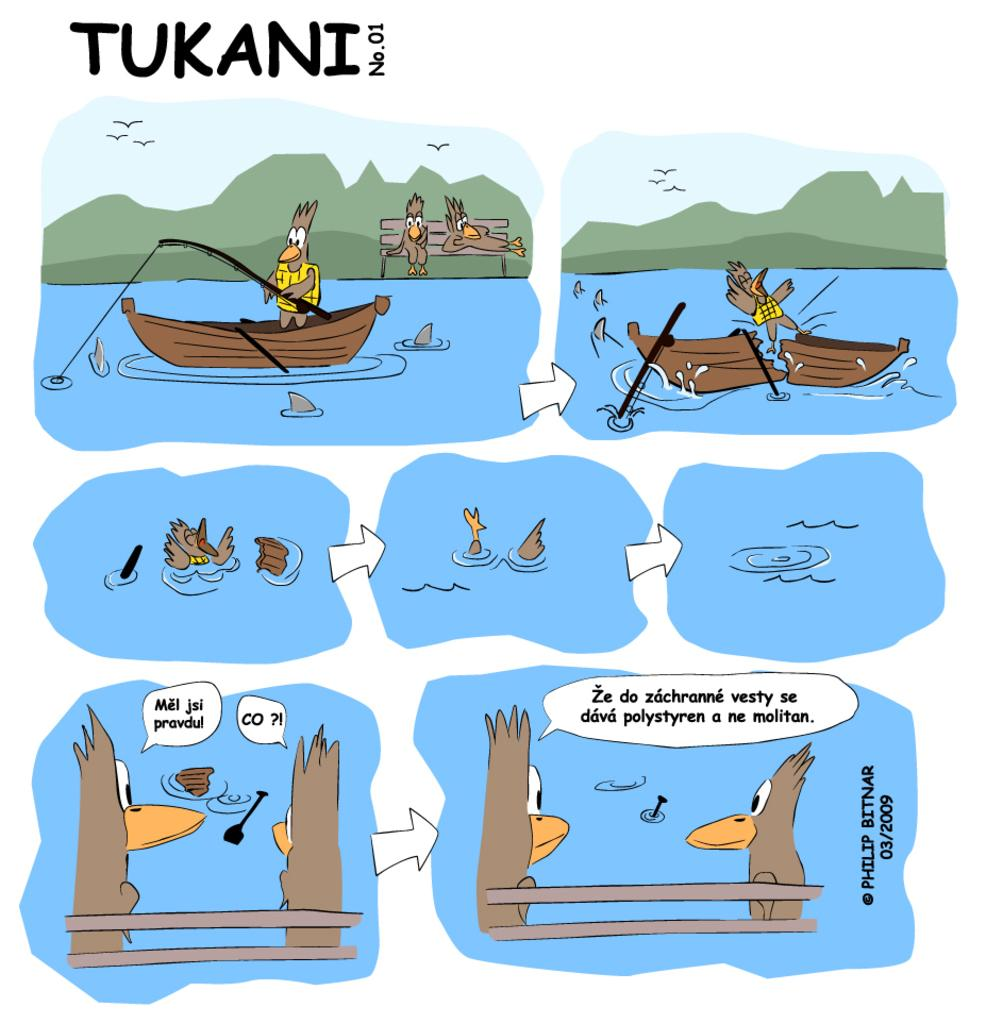What type of pictures are in the image? The image contains cartoon pictures. What is depicted in the cartoon pictures? There is a boat, a fishing rod, birds, a bench, trees, and the sky visible in the cartoon pictures. What activity might be taking place in the cartoon pictures? The presence of a boat and a fishing rod suggests that someone might be fishing in the cartoon pictures. What type of steel is used to construct the advice given in the image? There is no steel or advice present in the image; it contains cartoon pictures with various elements and objects, such as a boat, fishing rod, birds, bench, trees, and the sky. 